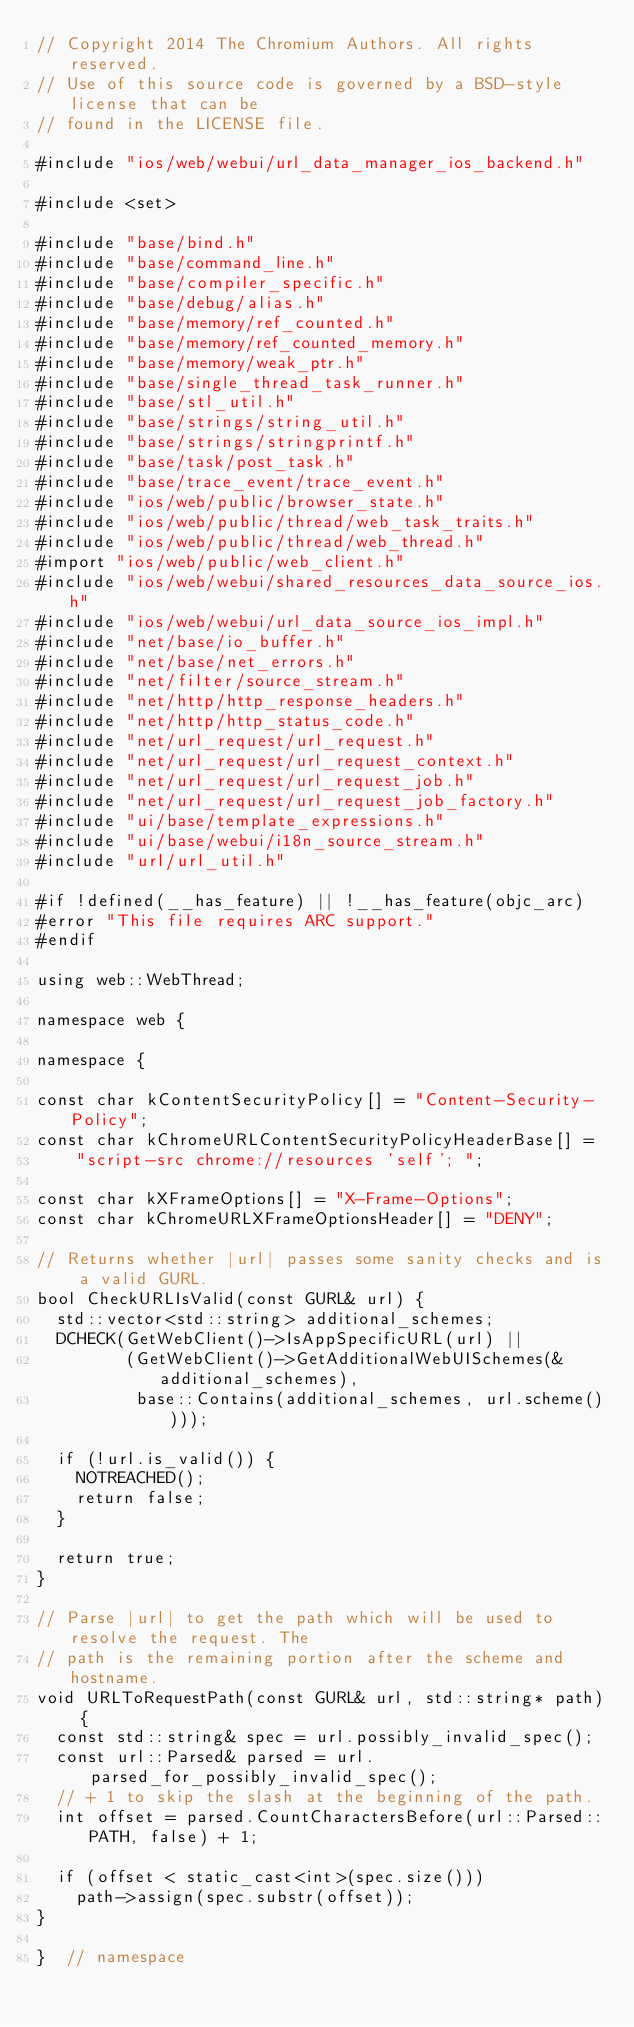<code> <loc_0><loc_0><loc_500><loc_500><_ObjectiveC_>// Copyright 2014 The Chromium Authors. All rights reserved.
// Use of this source code is governed by a BSD-style license that can be
// found in the LICENSE file.

#include "ios/web/webui/url_data_manager_ios_backend.h"

#include <set>

#include "base/bind.h"
#include "base/command_line.h"
#include "base/compiler_specific.h"
#include "base/debug/alias.h"
#include "base/memory/ref_counted.h"
#include "base/memory/ref_counted_memory.h"
#include "base/memory/weak_ptr.h"
#include "base/single_thread_task_runner.h"
#include "base/stl_util.h"
#include "base/strings/string_util.h"
#include "base/strings/stringprintf.h"
#include "base/task/post_task.h"
#include "base/trace_event/trace_event.h"
#include "ios/web/public/browser_state.h"
#include "ios/web/public/thread/web_task_traits.h"
#include "ios/web/public/thread/web_thread.h"
#import "ios/web/public/web_client.h"
#include "ios/web/webui/shared_resources_data_source_ios.h"
#include "ios/web/webui/url_data_source_ios_impl.h"
#include "net/base/io_buffer.h"
#include "net/base/net_errors.h"
#include "net/filter/source_stream.h"
#include "net/http/http_response_headers.h"
#include "net/http/http_status_code.h"
#include "net/url_request/url_request.h"
#include "net/url_request/url_request_context.h"
#include "net/url_request/url_request_job.h"
#include "net/url_request/url_request_job_factory.h"
#include "ui/base/template_expressions.h"
#include "ui/base/webui/i18n_source_stream.h"
#include "url/url_util.h"

#if !defined(__has_feature) || !__has_feature(objc_arc)
#error "This file requires ARC support."
#endif

using web::WebThread;

namespace web {

namespace {

const char kContentSecurityPolicy[] = "Content-Security-Policy";
const char kChromeURLContentSecurityPolicyHeaderBase[] =
    "script-src chrome://resources 'self'; ";

const char kXFrameOptions[] = "X-Frame-Options";
const char kChromeURLXFrameOptionsHeader[] = "DENY";

// Returns whether |url| passes some sanity checks and is a valid GURL.
bool CheckURLIsValid(const GURL& url) {
  std::vector<std::string> additional_schemes;
  DCHECK(GetWebClient()->IsAppSpecificURL(url) ||
         (GetWebClient()->GetAdditionalWebUISchemes(&additional_schemes),
          base::Contains(additional_schemes, url.scheme())));

  if (!url.is_valid()) {
    NOTREACHED();
    return false;
  }

  return true;
}

// Parse |url| to get the path which will be used to resolve the request. The
// path is the remaining portion after the scheme and hostname.
void URLToRequestPath(const GURL& url, std::string* path) {
  const std::string& spec = url.possibly_invalid_spec();
  const url::Parsed& parsed = url.parsed_for_possibly_invalid_spec();
  // + 1 to skip the slash at the beginning of the path.
  int offset = parsed.CountCharactersBefore(url::Parsed::PATH, false) + 1;

  if (offset < static_cast<int>(spec.size()))
    path->assign(spec.substr(offset));
}

}  // namespace
</code> 